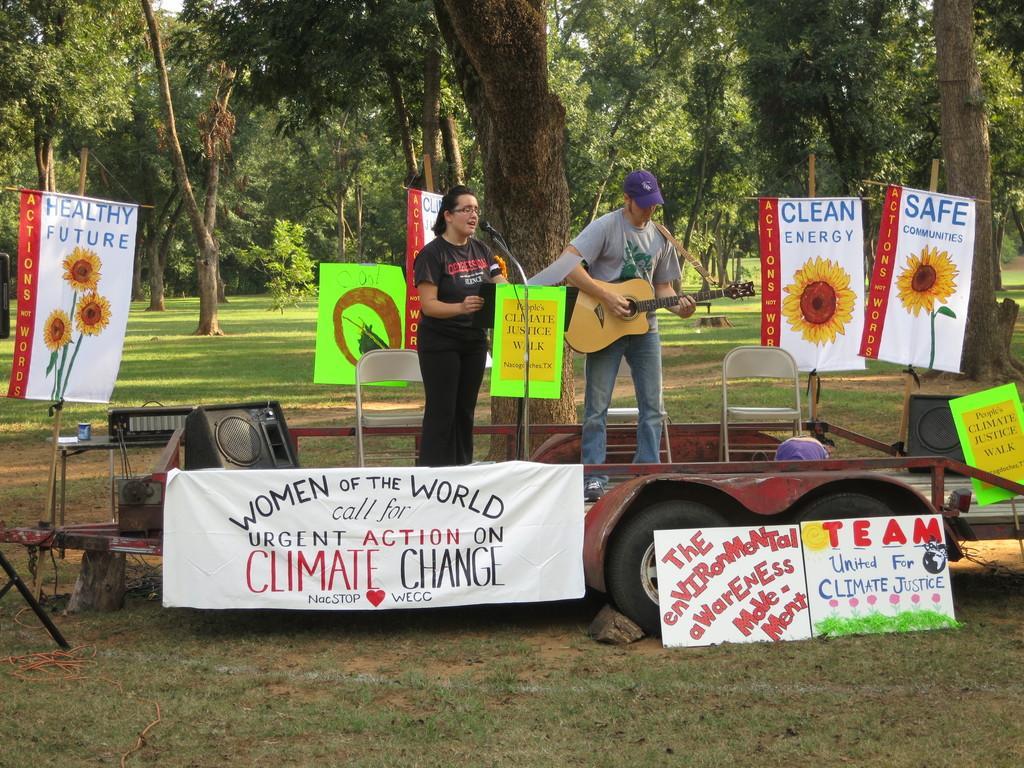How would you summarize this image in a sentence or two? In this image I can see two people where a man is holding a guitar. I can also a mic and few posters. In the background I can see number of trees, chairs and a speaker. 